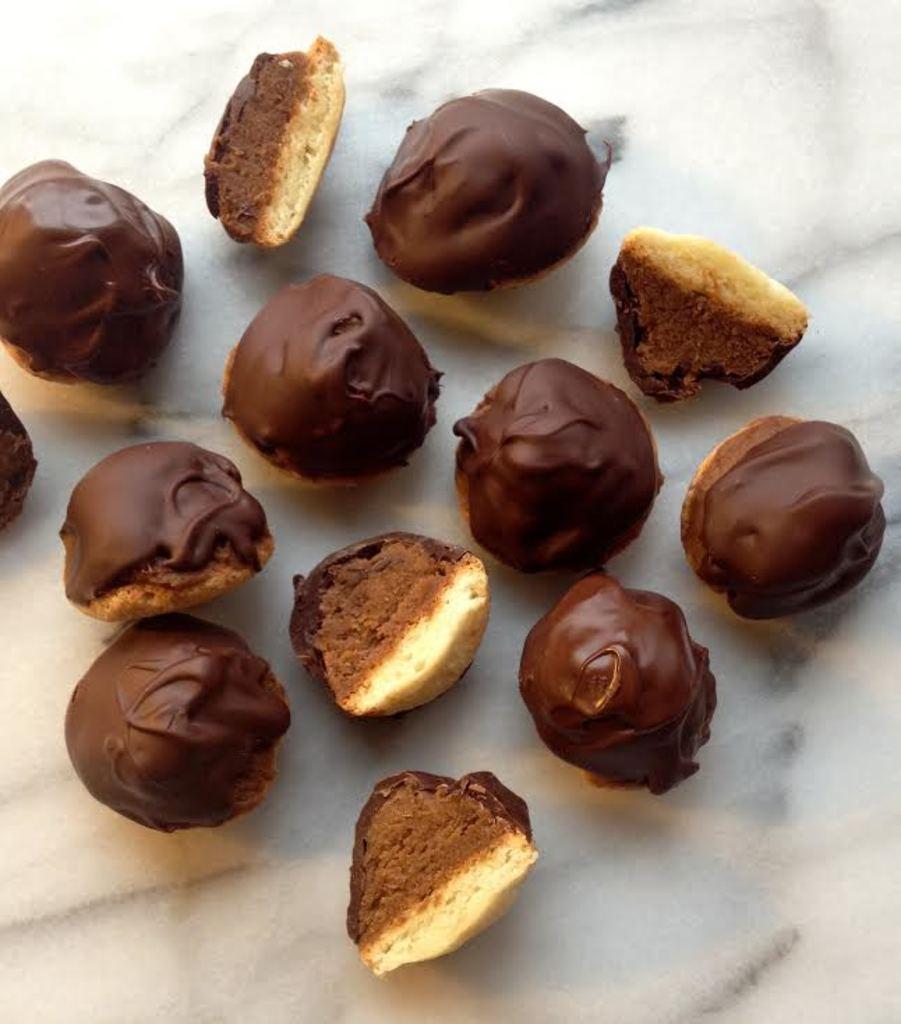In one or two sentences, can you explain what this image depicts? In this image I can see some food item on the white surface. 